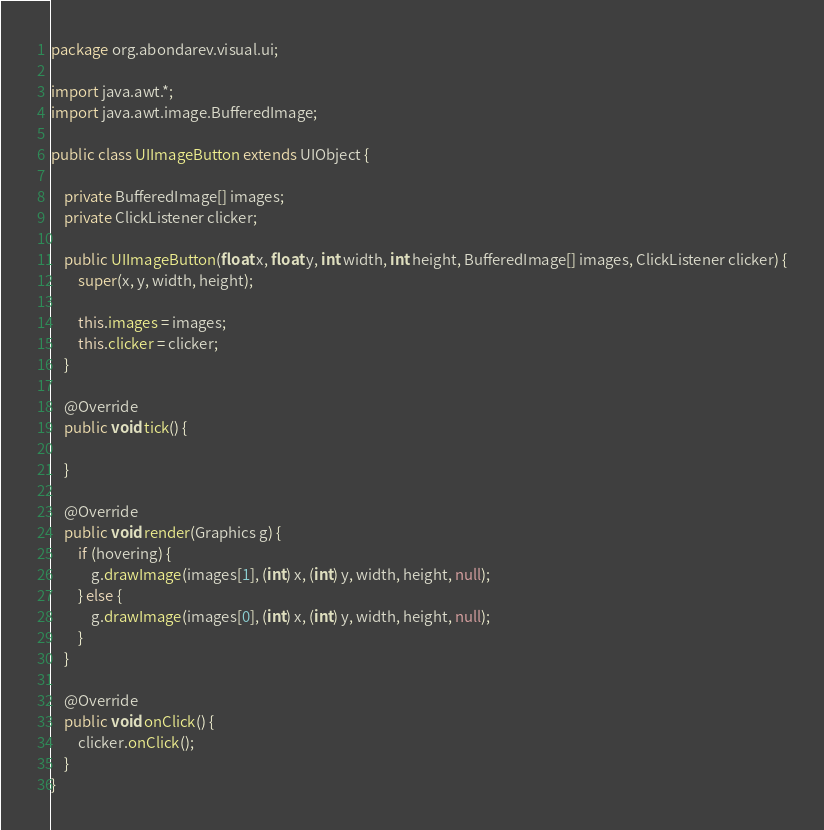<code> <loc_0><loc_0><loc_500><loc_500><_Java_>package org.abondarev.visual.ui;

import java.awt.*;
import java.awt.image.BufferedImage;

public class UIImageButton extends UIObject {

    private BufferedImage[] images;
    private ClickListener clicker;

    public UIImageButton(float x, float y, int width, int height, BufferedImage[] images, ClickListener clicker) {
        super(x, y, width, height);

        this.images = images;
        this.clicker = clicker;
    }

    @Override
    public void tick() {

    }

    @Override
    public void render(Graphics g) {
        if (hovering) {
            g.drawImage(images[1], (int) x, (int) y, width, height, null);
        } else {
            g.drawImage(images[0], (int) x, (int) y, width, height, null);
        }
    }

    @Override
    public void onClick() {
        clicker.onClick();
    }
}
</code> 